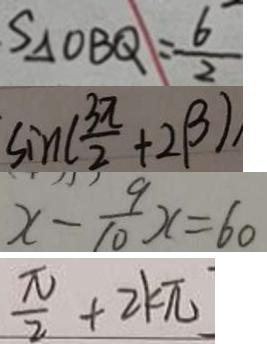Convert formula to latex. <formula><loc_0><loc_0><loc_500><loc_500>S _ { \Delta } O B Q = \frac { 6 } { 2 } 
 \sin ( \frac { 3 \pi } { 2 } + 2 \beta ) 
 x - \frac { 9 } { 1 0 } x = 6 0 
 \frac { \pi } { 2 } + 2 k \pi</formula> 